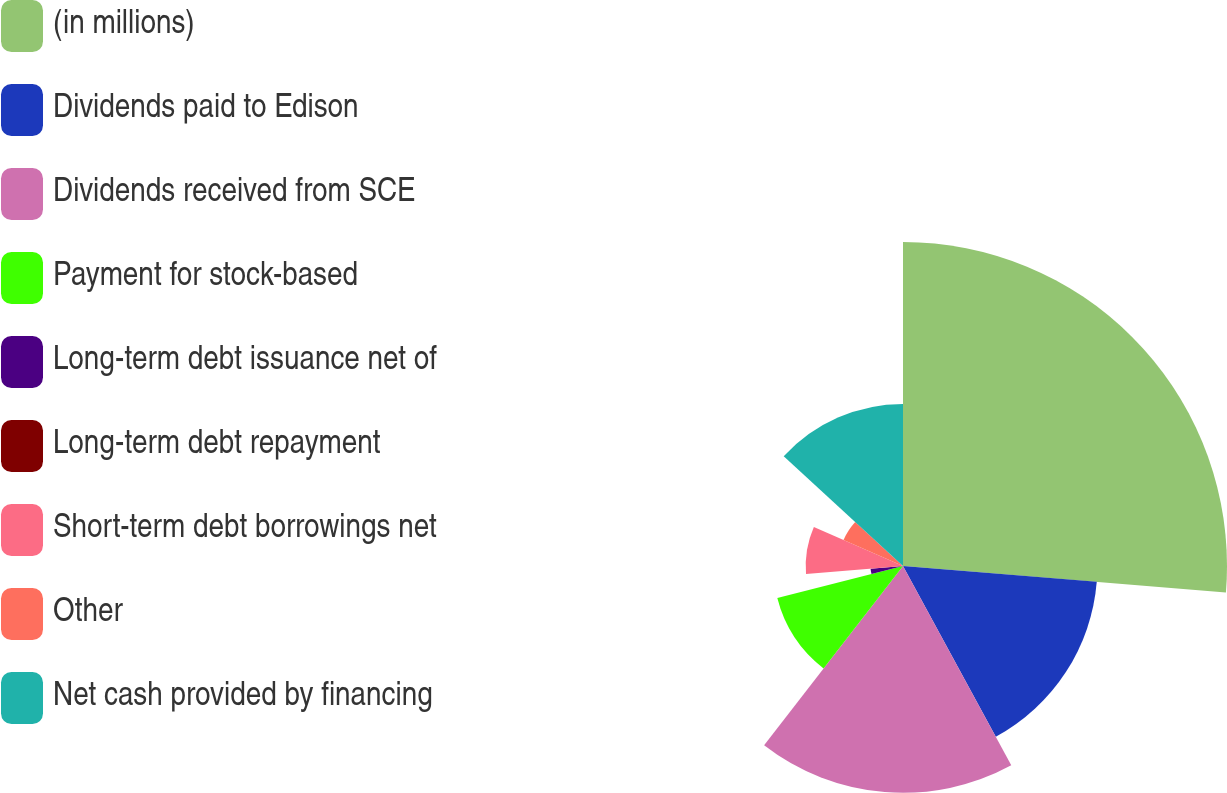<chart> <loc_0><loc_0><loc_500><loc_500><pie_chart><fcel>(in millions)<fcel>Dividends paid to Edison<fcel>Dividends received from SCE<fcel>Payment for stock-based<fcel>Long-term debt issuance net of<fcel>Long-term debt repayment<fcel>Short-term debt borrowings net<fcel>Other<fcel>Net cash provided by financing<nl><fcel>26.3%<fcel>15.78%<fcel>18.41%<fcel>10.53%<fcel>2.64%<fcel>0.01%<fcel>7.9%<fcel>5.27%<fcel>13.16%<nl></chart> 